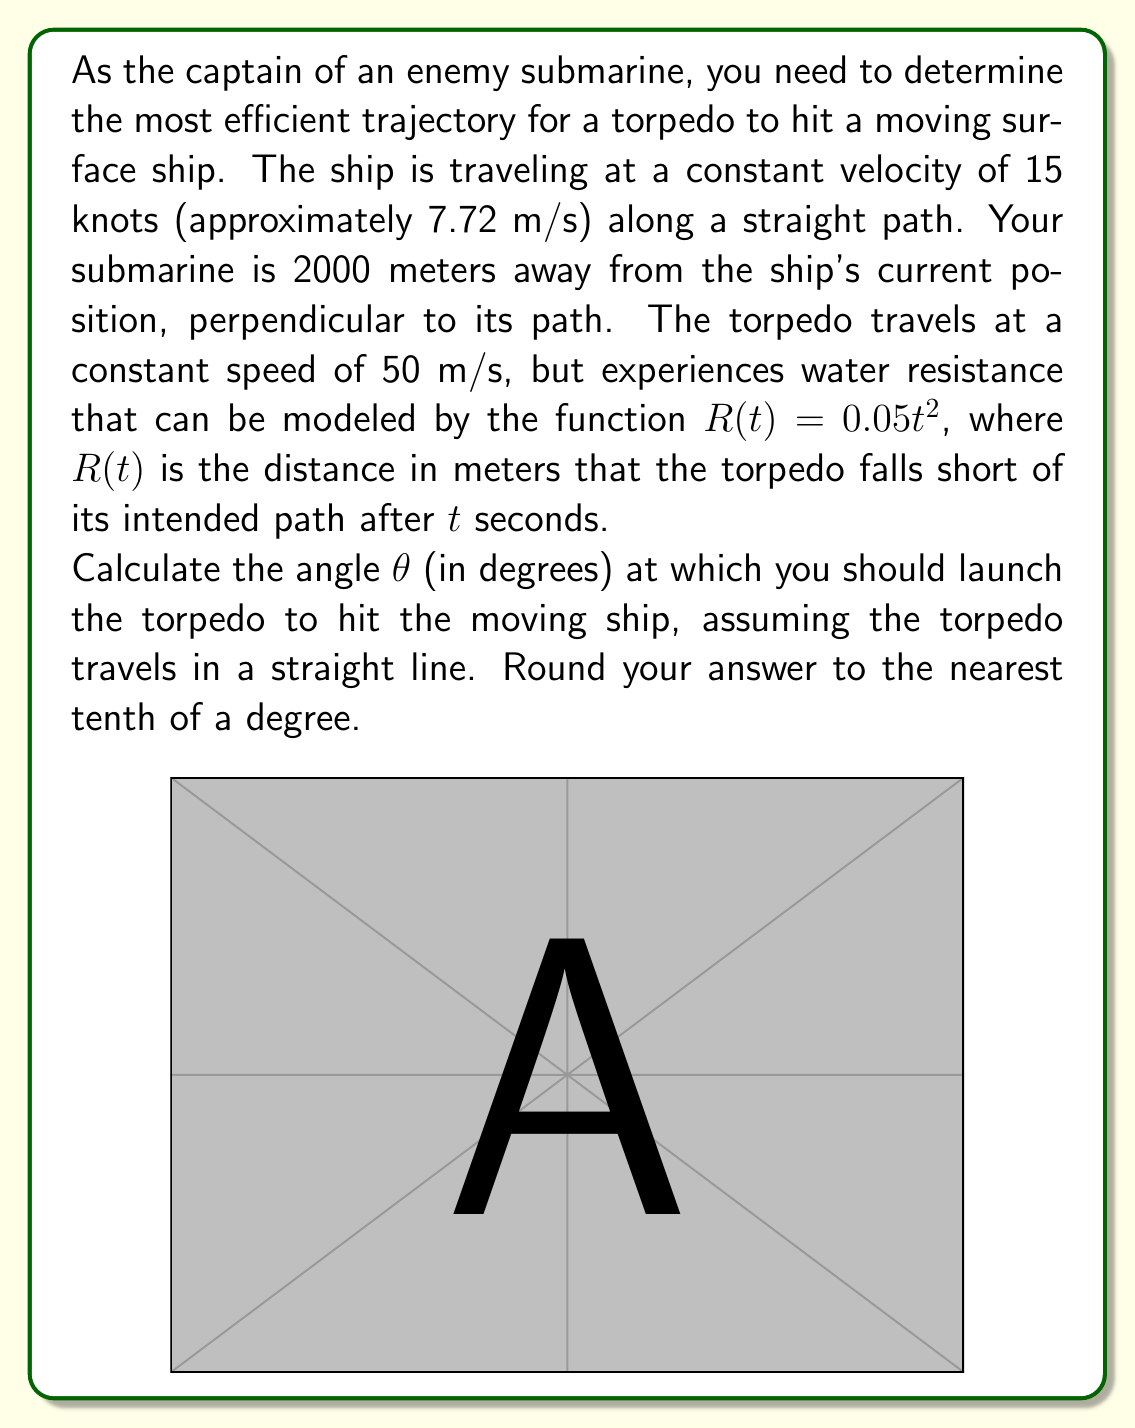Solve this math problem. Let's approach this problem step by step:

1) First, we need to determine the time it takes for the torpedo to reach the ship. Let's call this time $t$.

2) The distance the torpedo travels can be expressed as:
   $$\sqrt{2000^2 + (7.72t)^2} - 0.05t^2$$
   Where $7.72t$ is the distance the ship travels in $t$ seconds, and $0.05t^2$ is the distance the torpedo falls short due to water resistance.

3) We know the torpedo travels at 50 m/s, so we can set up the equation:
   $$50t = \sqrt{2000^2 + (7.72t)^2} - 0.05t^2$$

4) This equation is complex and difficult to solve analytically. We can use numerical methods or a graphing calculator to find that $t \approx 40.8$ seconds.

5) Now that we know the time, we can calculate the distance the ship travels:
   $$7.72 \cdot 40.8 \approx 315$$ meters

6) We can now treat this as a right triangle problem. The torpedo needs to travel from the submarine to where the ship will be after 40.8 seconds.

7) Using the arctangent function:
   $$\theta = \arctan(\frac{315}{2000})$$

8) Converting to degrees:
   $$\theta = \arctan(\frac{315}{2000}) \cdot \frac{180}{\pi} \approx 8.9^\circ$$

Therefore, the torpedo should be launched at an angle of approximately 8.9° to hit the moving ship.
Answer: $8.9^\circ$ 